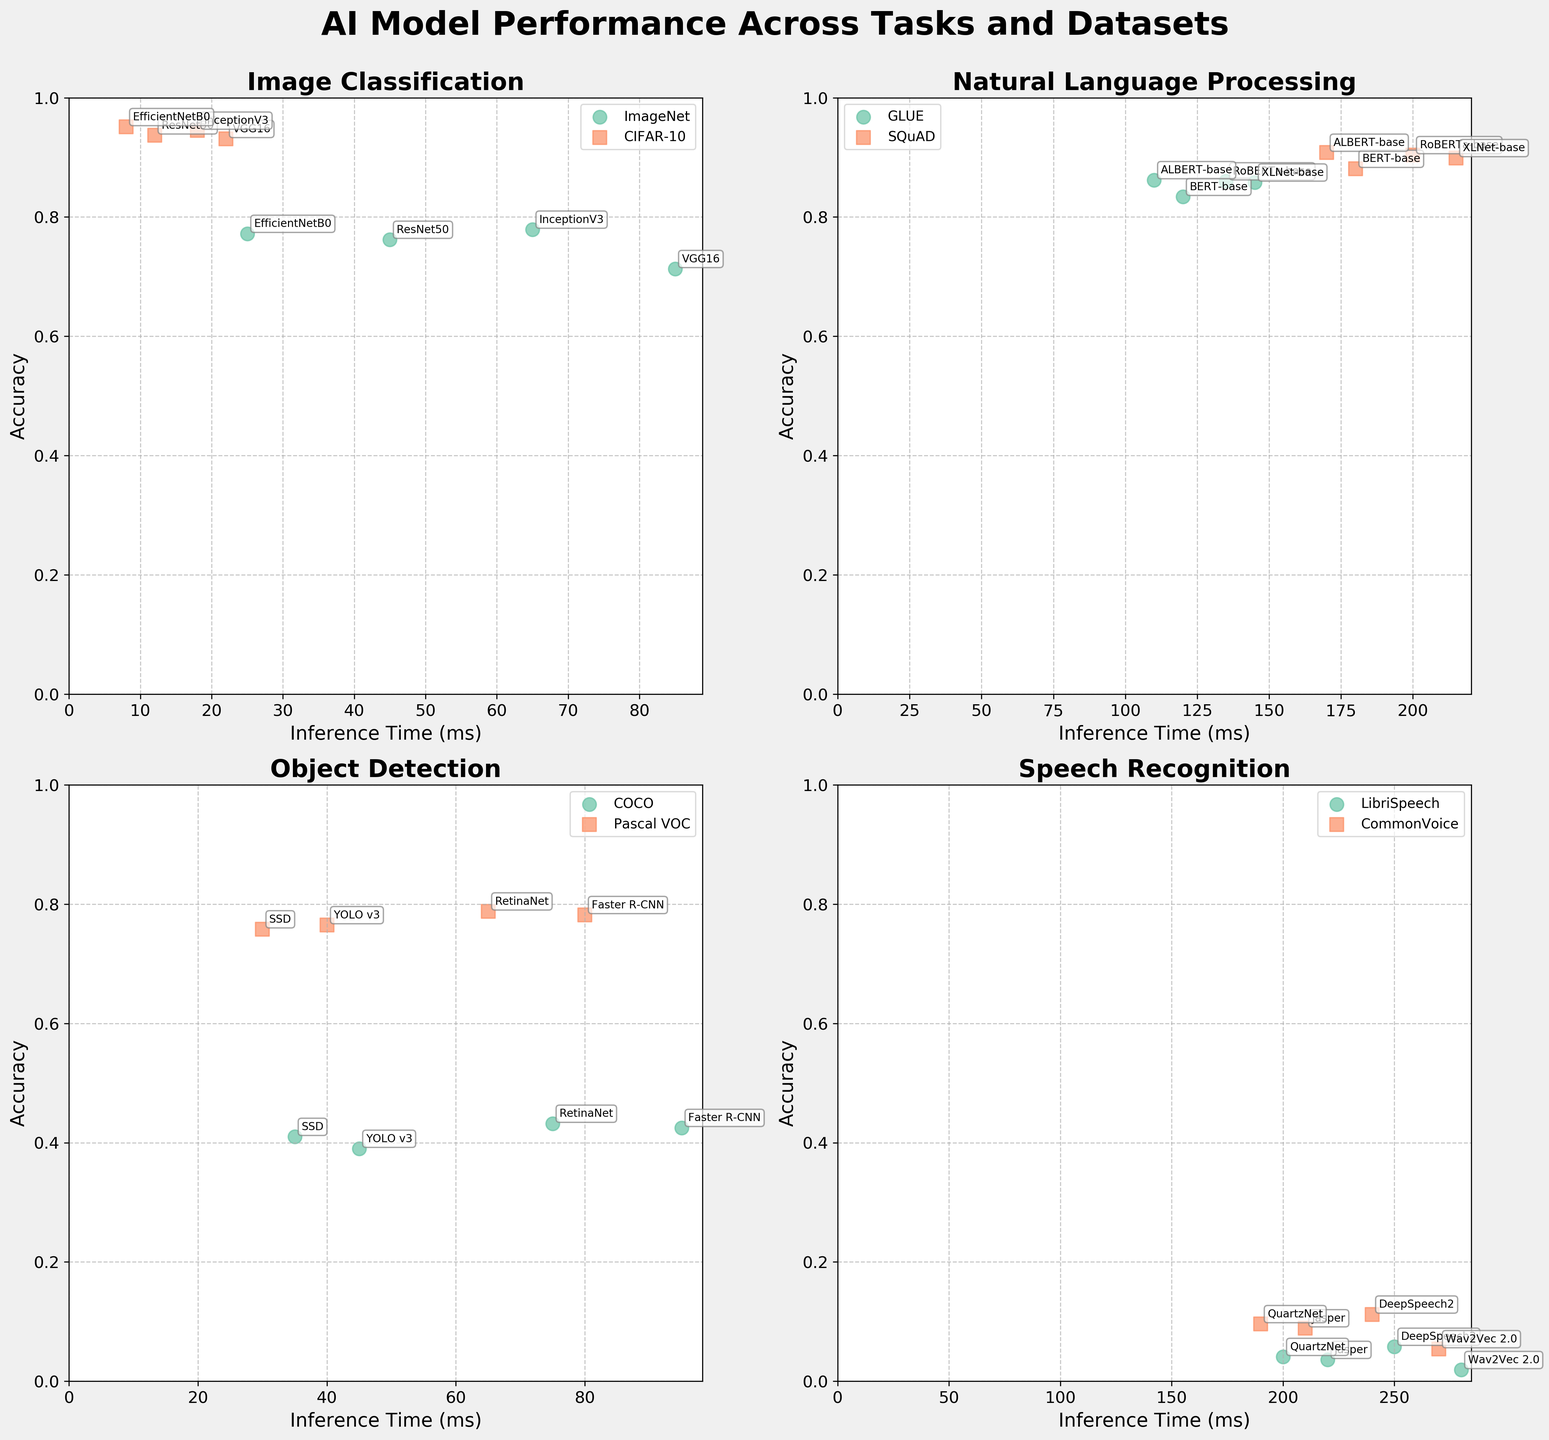Which model achieves the highest accuracy for image classification on the CIFAR-10 dataset? To find the model with the highest accuracy on the CIFAR-10 dataset, look at the 'image_classification' subplot and identify the point with the highest value on the y-axis for the CIFAR-10 dataset. The model corresponding to this point is EfficientNetB0 with a 0.951 accuracy.
Answer: EfficientNetB0 Which task shows the model with the longest inference time, and what is that time? To determine the task with the longest inference time, observe all subplots and identify the point farthest right on the x-axis. This corresponds to the speech recognition task with the model Wav2Vec 2.0, showing an inference time of 280 ms.
Answer: Speech recognition, 280 ms Compare the inference times of ALBERT-base and RoBERTa-base models on the GLUE dataset. Which one is faster? For GLUE dataset, on the natural_language_processing subplot, locate the points for ALBERT-base and RoBERTa-base. ALBERT-base (110 ms) is faster compared to RoBERTa-base (135 ms).
Answer: ALBERT-base What is the difference in accuracy between Faster R-CNN and RetinaNet on the COCO dataset? On the object detection subplot for the COCO dataset, Faster R-CNN has an accuracy of 0.425, while RetinaNet has an accuracy of 0.432. The difference is 0.432 - 0.425 = 0.007.
Answer: 0.007 Which dataset shows more variation in model accuracy for image classification, ImageNet or CIFAR-10? On the image_classification subplot, compare the range of accuracy values for ImageNet and CIFAR-10 datasets. ImageNet ranges from 0.713 to 0.779, a variation of 0.066. CIFAR-10 ranges from 0.931 to 0.951, a variation of 0.02. ImageNet thus shows more variation.
Answer: ImageNet Which combination of task and dataset demonstrates the lowest accuracy overall, and what is that value? In all the subplots, identify the point closest to the bottom of the y-axis, representing the lowest accuracy. This occurs in the speech_recognition task with the LibriSpeech dataset, where Wav2Vec 2.0 achieves an accuracy of 0.019.
Answer: Speech recognition, LibriSpeech, 0.019 Are there any tasks where the inference times for different models are relatively similar, and if so, which task? Look at the subplots for the range of inference times within each task. The object detection task shows relatively similar inference times for models on the Pascal VOC dataset, ranging from 30 ms to 80 ms.
Answer: Object detection, Pascal VOC What is the average accuracy of models on the SQuAD dataset for the natural language processing task? On the natural_language_processing subplot for SQuAD dataset, sum the accuracies of BERT-base (0.881), RoBERTa-base (0.904), XLNet-base (0.899), and ALBERT-base (0.908). The average is (0.881 + 0.904 + 0.899 + 0.908)/4 = 0.898.
Answer: 0.898 Which task shows the closest grouping of model accuracies around a central value, and what is that approximate value? For each subplot, assess the clustering of points around a central y-axis value. The natural_language_processing task with the SQuAD dataset shows model accuracies closely grouped around ~0.9.
Answer: Natural Language Processing, ~0.9 